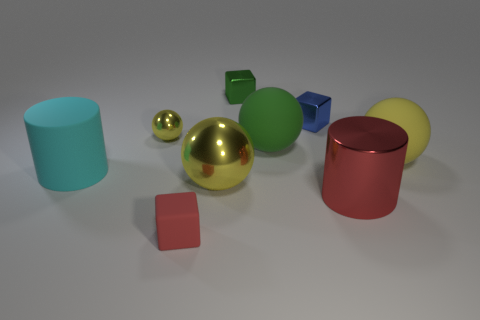The cyan rubber object that is the same shape as the large red metal thing is what size?
Provide a succinct answer. Large. Does the matte cube have the same color as the metallic cylinder?
Your answer should be compact. Yes. Are there any red things that have the same size as the blue cube?
Ensure brevity in your answer.  Yes. What number of tiny cubes are to the left of the small blue metallic thing and behind the tiny yellow shiny object?
Your answer should be compact. 1. There is a large metallic cylinder; what number of big green balls are in front of it?
Keep it short and to the point. 0. Is there a cyan object of the same shape as the big red metal object?
Your answer should be compact. Yes. Is the shape of the red rubber thing the same as the yellow shiny thing in front of the yellow rubber ball?
Make the answer very short. No. How many cubes are either blue shiny things or small yellow objects?
Give a very brief answer. 1. There is a big yellow thing on the left side of the large red cylinder; what shape is it?
Your answer should be compact. Sphere. What number of other tiny blocks are the same material as the small blue cube?
Give a very brief answer. 1. 